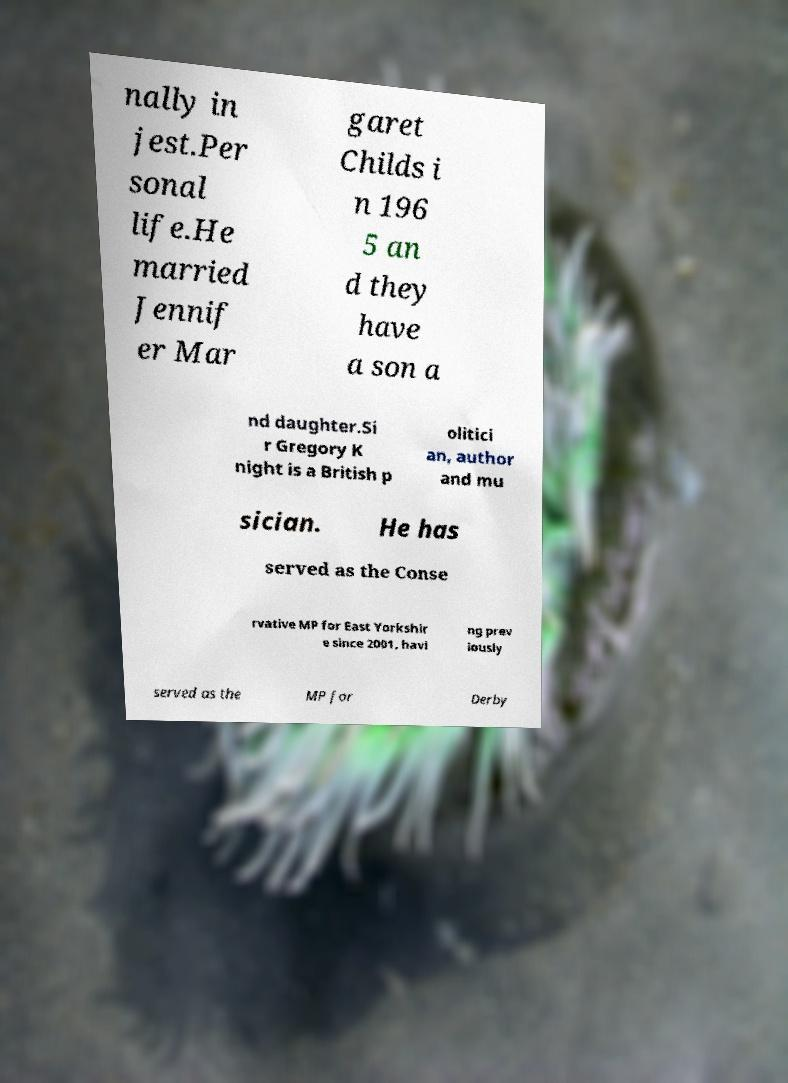For documentation purposes, I need the text within this image transcribed. Could you provide that? nally in jest.Per sonal life.He married Jennif er Mar garet Childs i n 196 5 an d they have a son a nd daughter.Si r Gregory K night is a British p olitici an, author and mu sician. He has served as the Conse rvative MP for East Yorkshir e since 2001, havi ng prev iously served as the MP for Derby 